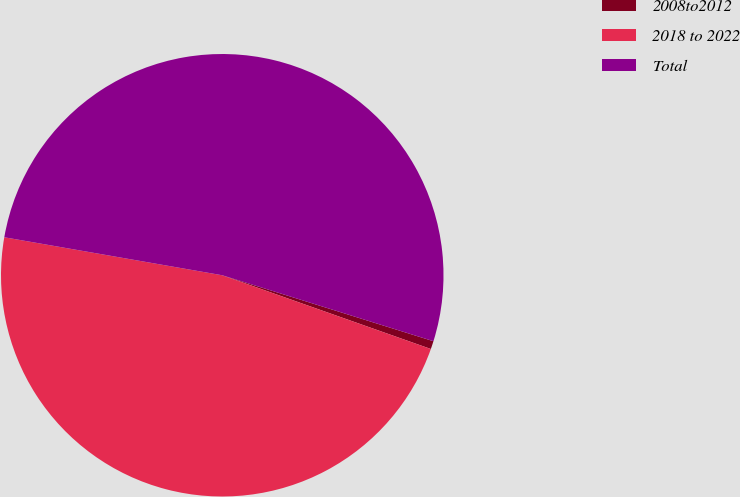<chart> <loc_0><loc_0><loc_500><loc_500><pie_chart><fcel>2008to2012<fcel>2018 to 2022<fcel>Total<nl><fcel>0.59%<fcel>47.34%<fcel>52.07%<nl></chart> 